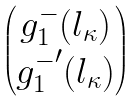Convert formula to latex. <formula><loc_0><loc_0><loc_500><loc_500>\begin{pmatrix} g _ { 1 } ^ { - } ( l _ { \kappa } ) \\ { g _ { 1 } ^ { - } } ^ { \prime } ( l _ { \kappa } ) \end{pmatrix}</formula> 